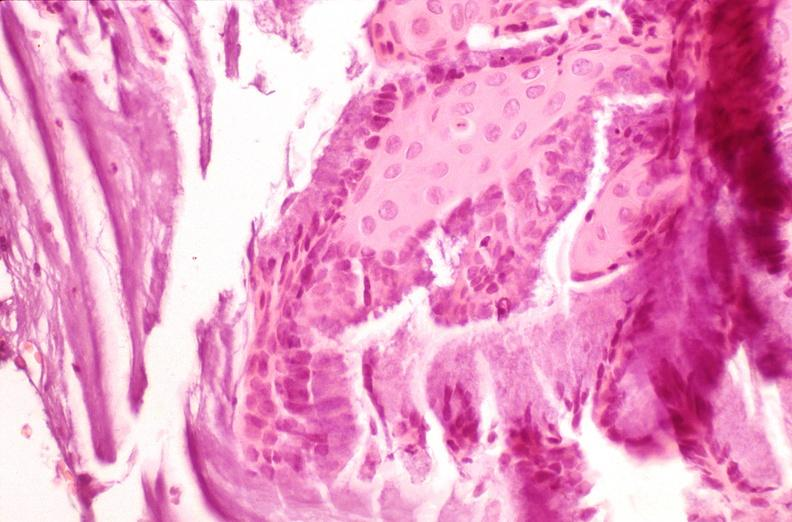s female reproductive present?
Answer the question using a single word or phrase. Yes 